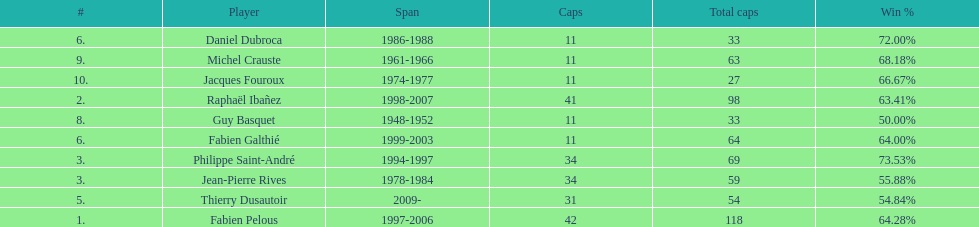How many players have spans above three years? 6. 